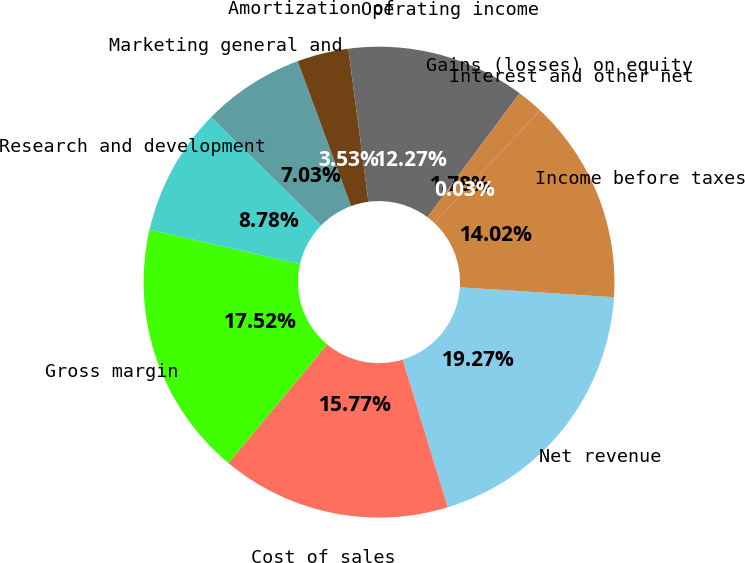Convert chart. <chart><loc_0><loc_0><loc_500><loc_500><pie_chart><fcel>Net revenue<fcel>Cost of sales<fcel>Gross margin<fcel>Research and development<fcel>Marketing general and<fcel>Amortization of<fcel>Operating income<fcel>Gains (losses) on equity<fcel>Interest and other net<fcel>Income before taxes<nl><fcel>19.27%<fcel>15.77%<fcel>17.52%<fcel>8.78%<fcel>7.03%<fcel>3.53%<fcel>12.27%<fcel>1.78%<fcel>0.03%<fcel>14.02%<nl></chart> 